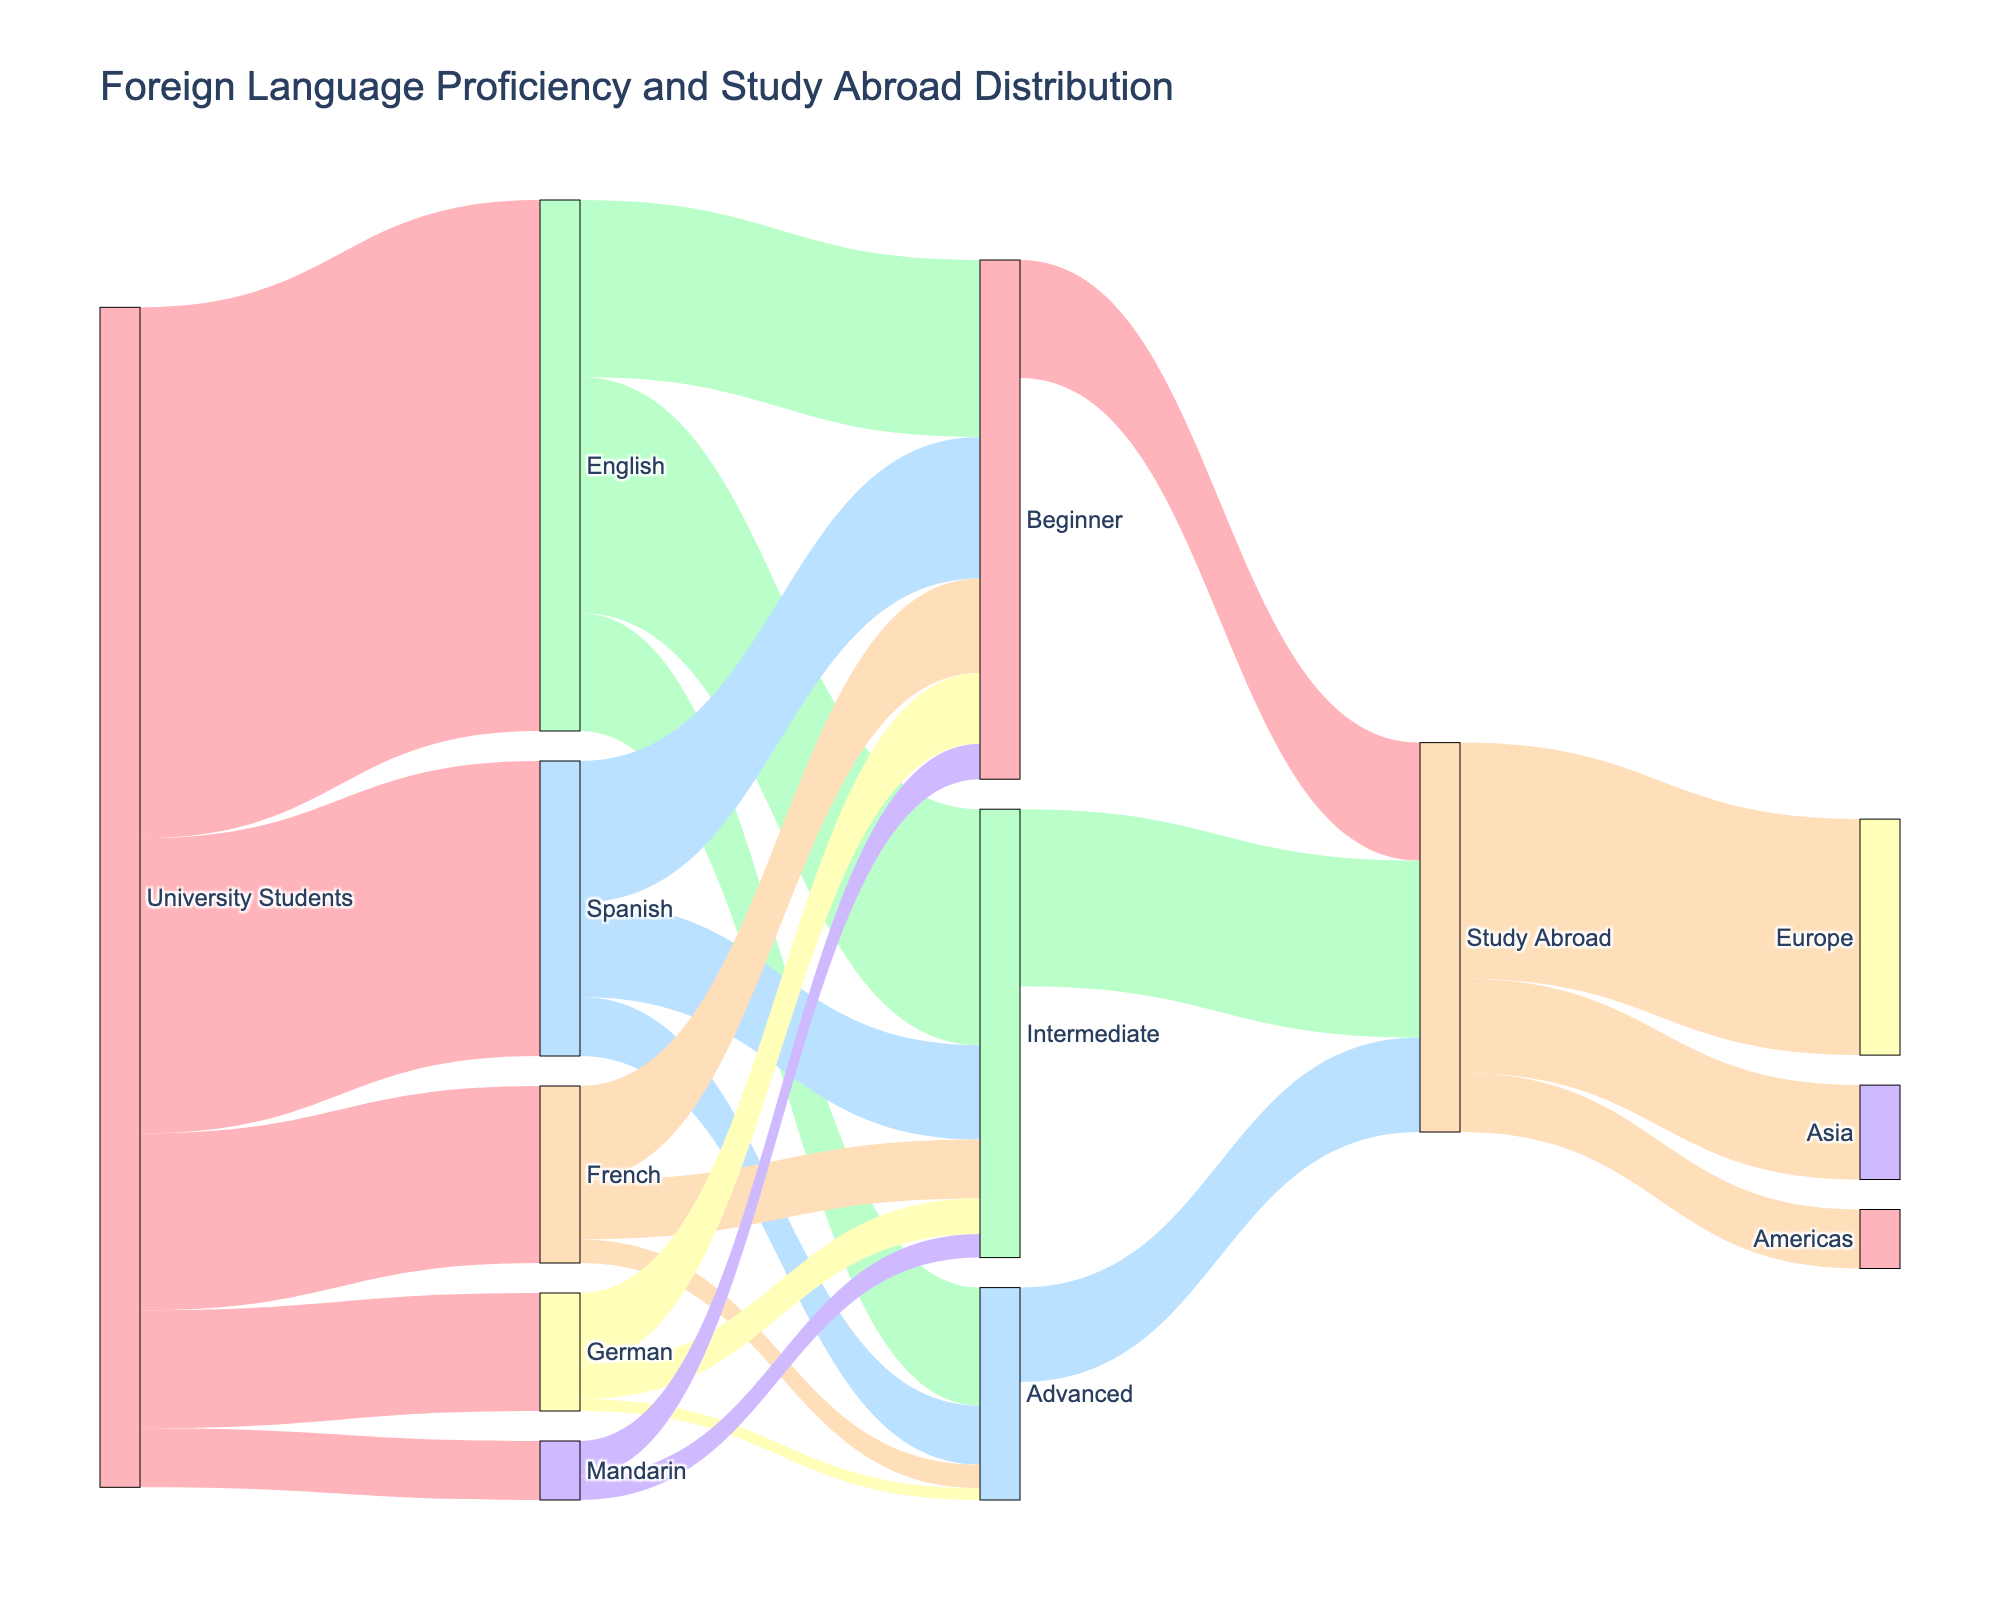What is the title of the figure? The title of the figure is located at the top and labeled in larger font size. It reads "Foreign Language Proficiency and Study Abroad Distribution".
Answer: Foreign Language Proficiency and Study Abroad Distribution Which language has the highest number of university students? By observing the first set of links from "University Students", we can see that "English" has the thickest link, indicating the highest number.
Answer: English What is the total number of university students proficient in French? To find this, we look at the link from 'University Students' to 'French', which indicates the number 15.
Answer: 15 What is the sum of university students who are beginners in all languages? We add the values of beginners from all languages: English (15) + Spanish (12) + French (8) + German (6) + Mandarin (3), which totals to 44.
Answer: 44 Compare the number of intermediate-level students in Spanish and French. Which group is larger? By looking at the links, Spanish shows 8 intermediate-level students, while French has 5. Therefore, Spanish has more intermediate-level students.
Answer: Spanish How many students are studying abroad in Europe? To find this, we look into the 'Study Abroad' to 'Europe' link, which shows a value of 20.
Answer: 20 What is the total number of students who are planning to study abroad? We sum the values of students from 'Beginner' (10), 'Intermediate' (15), and 'Advanced' (8) who are studying abroad. Therefore, 10 + 15 + 8 = 33.
Answer: 33 Among the students who study German, how many have an advanced proficiency level? By identifying the link from 'German' to 'Advanced', we can see there's 1 German student with advanced proficiency.
Answer: 1 How many students are proficient in Spanish at an advanced level? The value representing advanced proficiency in Spanish is given directly by the link from 'Spanish' to 'Advanced', which is 5.
Answer: 5 